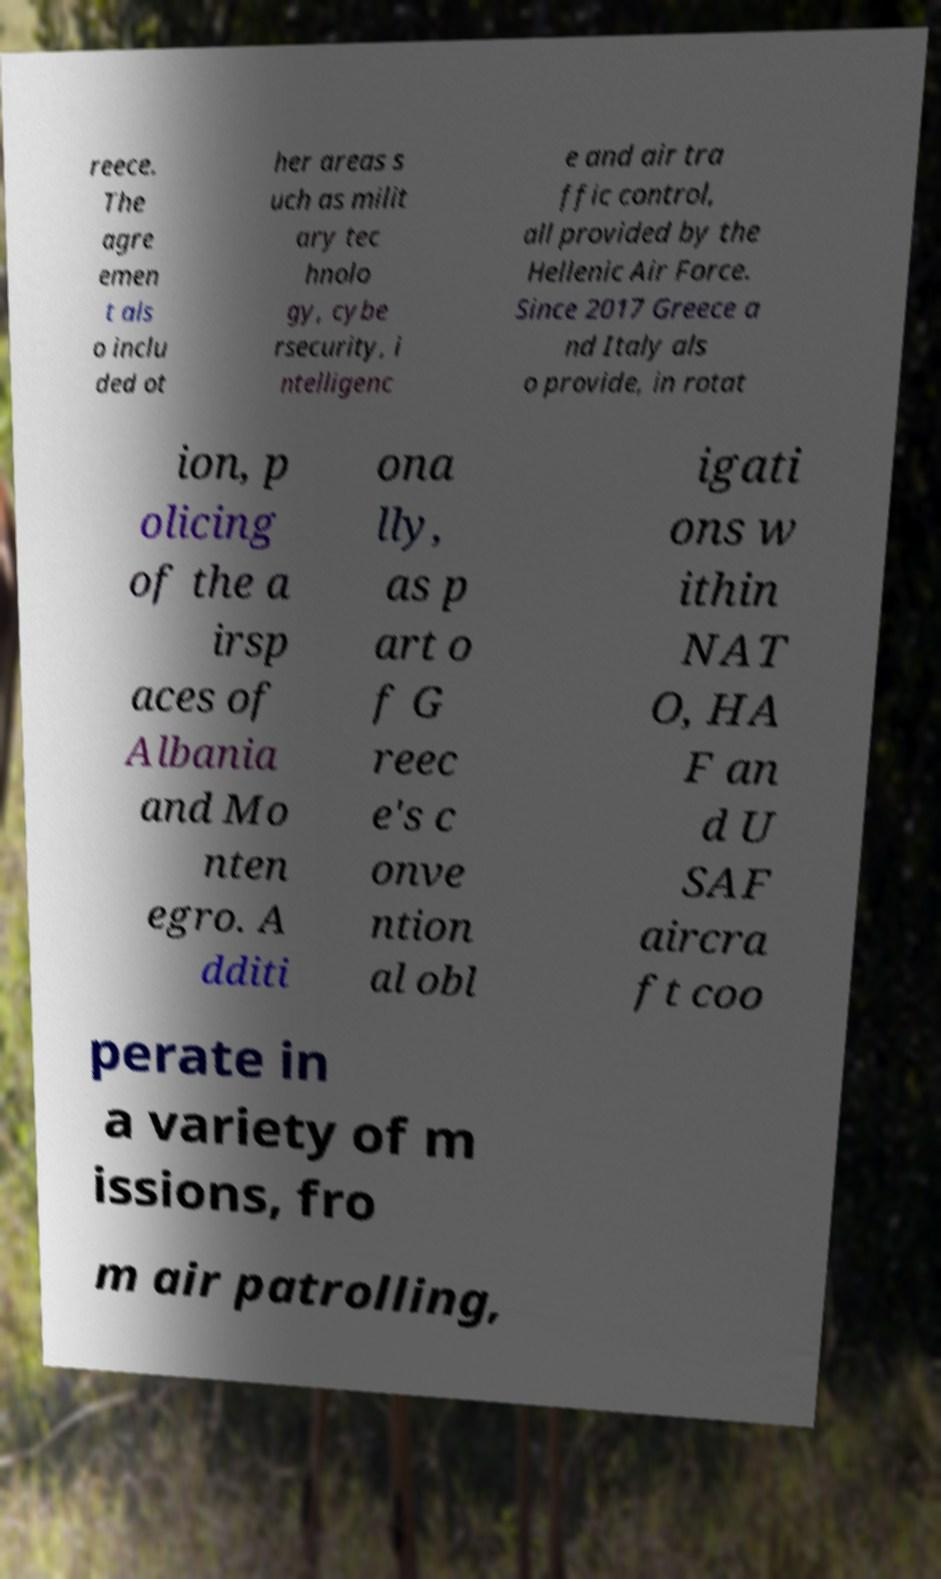I need the written content from this picture converted into text. Can you do that? reece. The agre emen t als o inclu ded ot her areas s uch as milit ary tec hnolo gy, cybe rsecurity, i ntelligenc e and air tra ffic control, all provided by the Hellenic Air Force. Since 2017 Greece a nd Italy als o provide, in rotat ion, p olicing of the a irsp aces of Albania and Mo nten egro. A dditi ona lly, as p art o f G reec e's c onve ntion al obl igati ons w ithin NAT O, HA F an d U SAF aircra ft coo perate in a variety of m issions, fro m air patrolling, 